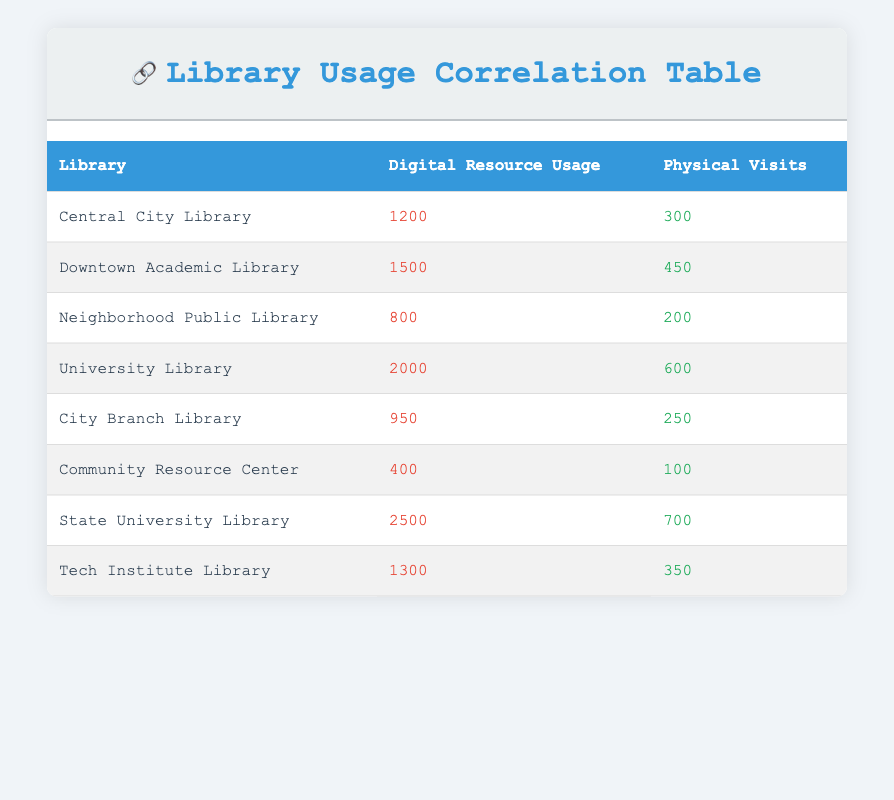What is the highest digital resource usage recorded among the libraries? By examining the table, we can see the digital resource usage for each library. The highest value is 2500 for the State University Library.
Answer: 2500 Which library has the fewest physical visits? Looking at the physical visits column, the Community Resource Center has the lowest number of visits, which is 100.
Answer: 100 What is the total digital resource usage for all libraries combined? To find the total, we need to sum the digital resource usage for all libraries: 1200 + 1500 + 800 + 2000 + 950 + 400 + 2500 + 1300 = 8850.
Answer: 8850 Is the number of physical visits for Downtown Academic Library greater than the average number of physical visits for all libraries? First, we calculate the average physical visits: the sum of all physical visits is 300 + 450 + 200 + 600 + 250 + 100 + 700 + 350 = 2650; there are 8 libraries, so the average is 2650 / 8 = 331.25. Since Downtown Academic Library has 450 visits, which is greater than 331.25, the answer is yes.
Answer: Yes Which library records the highest ratio of digital resource usage to physical visits? To determine this, we calculate the ratio for each library: Central City Library (1200/300=4), Downtown Academic Library (1500/450≈3.33), Neighborhood Public Library (800/200=4), University Library (2000/600≈3.33), City Branch Library (950/250=3.8), Community Resource Center (400/100=4), State University Library (2500/700≈3.57), Tech Institute Library (1300/350≈3.71). The highest ratio, 4, occurs at Central City Library, Neighborhood Public Library, and Community Resource Center.
Answer: Central City Library, Neighborhood Public Library, Community Resource Center 